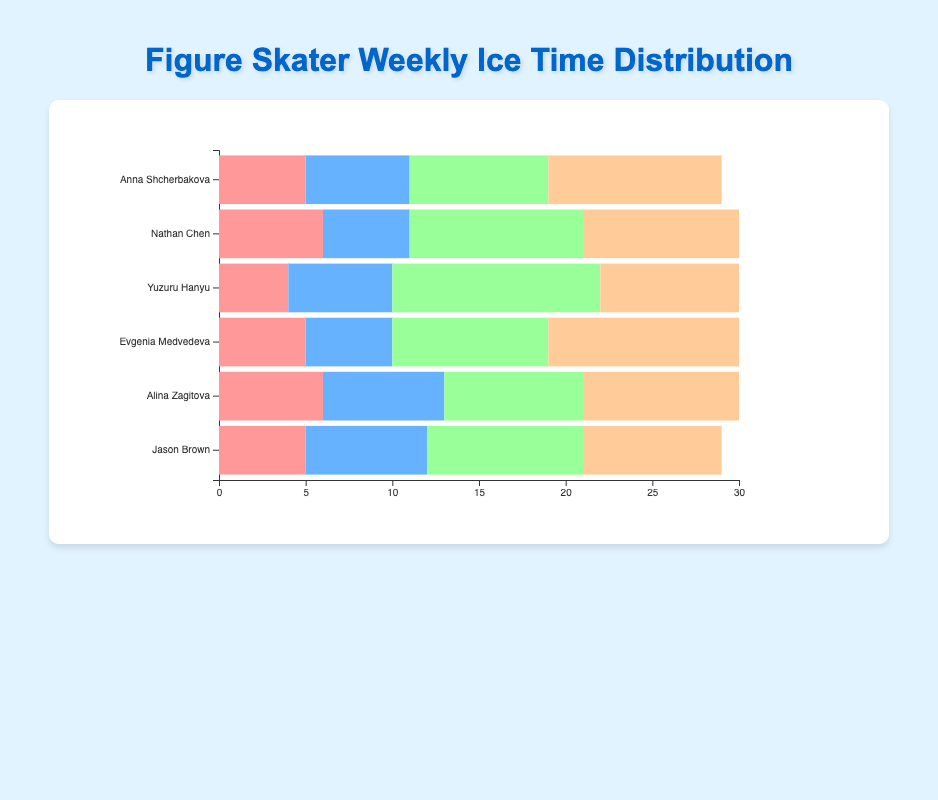Which figure skater spends the most time on free skate? First, we identify all the free skate hours: Anna Shcherbakova (10), Nathan Chen (9), Yuzuru Hanyu (8), Evgenia Medvedeva (11), Alina Zagitova (9), Jason Brown (8). The highest value is 11 hours, belonging to Evgenia Medvedeva.
Answer: Evgenia Medvedeva Who spends more time on strength training, Anna Shcherbakova or Yuzuru Hanyu? Anna Shcherbakova spends 5 hours on strength training, while Yuzuru Hanyu spends 4 hours. Therefore, Anna Shcherbakova spends more time.
Answer: Anna Shcherbakova What is the total ice time spent by Nathan Chen on choreography and free skate? Nathan Chen's choreography time is 10 hours, and his free skate time is 9 hours. Adding these together gives us 10 + 9 = 19 hours.
Answer: 19 hours Which practice type, among all skaters, has the most substantial individual time allocation in choreography? Checking the hours for choreography, Anna Shcherbakova (8), Nathan Chen (10), Yuzuru Hanyu (12), Evgenia Medvedeva (9), Alina Zagitova (8), and Jason Brown (9), the highest is 12 hours by Yuzuru Hanyu.
Answer: Yuzuru Hanyu In total, how many hours does Jason Brown dedicate to endurance training and strength training combined? Jason Brown spends 7 hours on endurance training and 5 hours on strength training. Summing these, we get 7 + 5 = 12 hours.
Answer: 12 hours How does the total weekly ice time of Yuzuru Hanyu compare to Alina Zagitova? Yuzuru Hanyu's total ice time is calculated by summing his hours (4 + 6 + 12 + 8 = 30), and Alina Zagitova's total is (6 + 7 + 8 + 9 = 30). Both skaters spend the same amount of time, 30 hours per week each.
Answer: Equal What is the average time spent on strength training by all skaters? We sum up the strength training hours for all skaters: 5 (Anna) + 6 (Nathan) + 4 (Yuzuru) + 5 (Evgenia) + 6 (Alina) + 5 (Jason) = 31 hours. Dividing by the number of skaters (6) gives us 31 / 6 = 5.17 hours.
Answer: 5.17 hours Which two skaters spend equal time on free skate? Examining the free skate hours: Anna Shcherbakova (10), Nathan Chen (9), Yuzuru Hanyu (8), Evgenia Medvedeva (11), Alina Zagitova (9), Jason Brown (8), we see both Nathan Chen and Alina Zagitova spend 9 hours on free skate.
Answer: Nathan Chen and Alina Zagitova Which skater dedicates the most time to choreography compared to their total weekly ice time? Calculate the ratio of choreography time to total time for each skater: Anna Shcherbakova (8/29), Nathan Chen (10/30), Yuzuru Hanyu (12/30), Evgenia Medvedeva (9/30), Alina Zagitova (8/30), Jason Brown (9/29). Yuzuru Hanyu's ratio is the highest at 12/30 = 0.4 or 40%.
Answer: Yuzuru Hanyu 